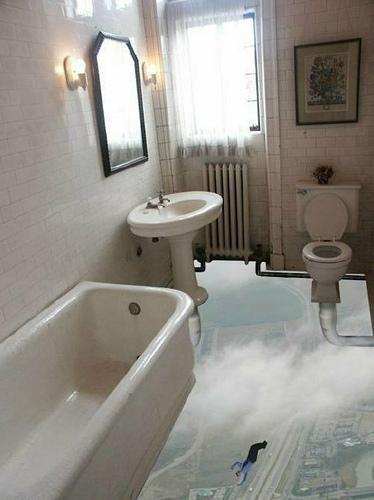How many horses are there?
Give a very brief answer. 0. 